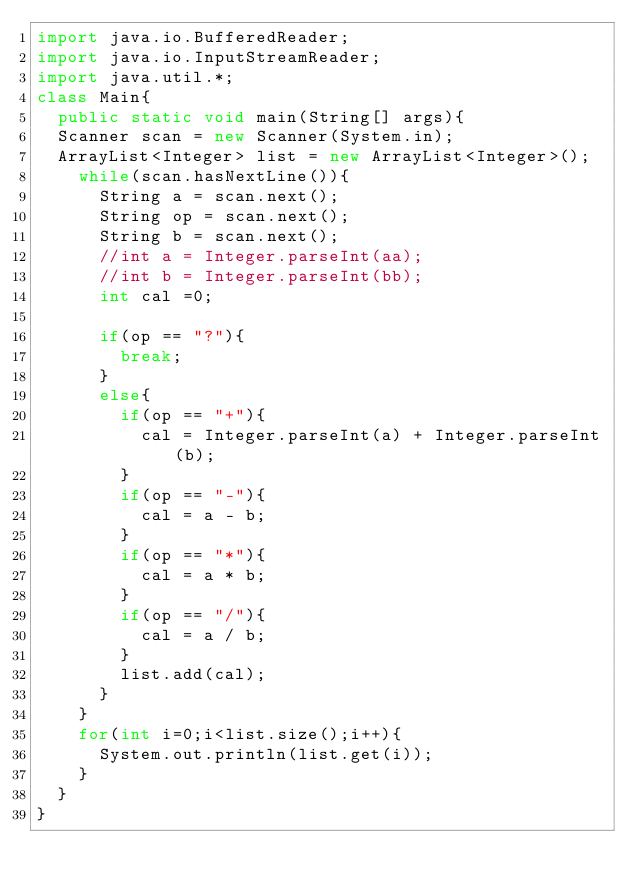<code> <loc_0><loc_0><loc_500><loc_500><_Java_>import java.io.BufferedReader;
import java.io.InputStreamReader;
import java.util.*;
class Main{
	public static void main(String[] args){
	Scanner scan = new Scanner(System.in);
	ArrayList<Integer> list = new ArrayList<Integer>();
		while(scan.hasNextLine()){
			String a = scan.next();
			String op = scan.next();
			String b = scan.next();
			//int a = Integer.parseInt(aa);
			//int b = Integer.parseInt(bb);
			int cal =0;
			
			if(op == "?"){
				break;
			}
			else{
				if(op == "+"){
					cal = Integer.parseInt(a) + Integer.parseInt(b);
				}
				if(op == "-"){
					cal = a - b;
				}
				if(op == "*"){
					cal = a * b;
				}
				if(op == "/"){
					cal = a / b;
				}
				list.add(cal);			
			}
		}
		for(int i=0;i<list.size();i++){
			System.out.println(list.get(i));
		}
	}
}</code> 